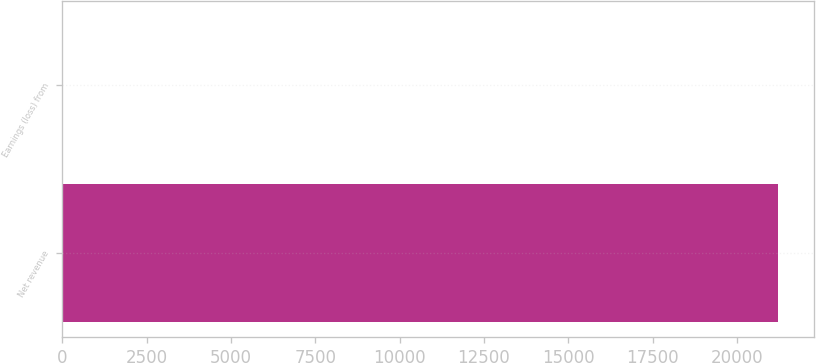Convert chart. <chart><loc_0><loc_0><loc_500><loc_500><bar_chart><fcel>Net revenue<fcel>Earnings (loss) from<nl><fcel>21210<fcel>0.1<nl></chart> 